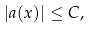Convert formula to latex. <formula><loc_0><loc_0><loc_500><loc_500>| a ( x ) | \leq C ,</formula> 